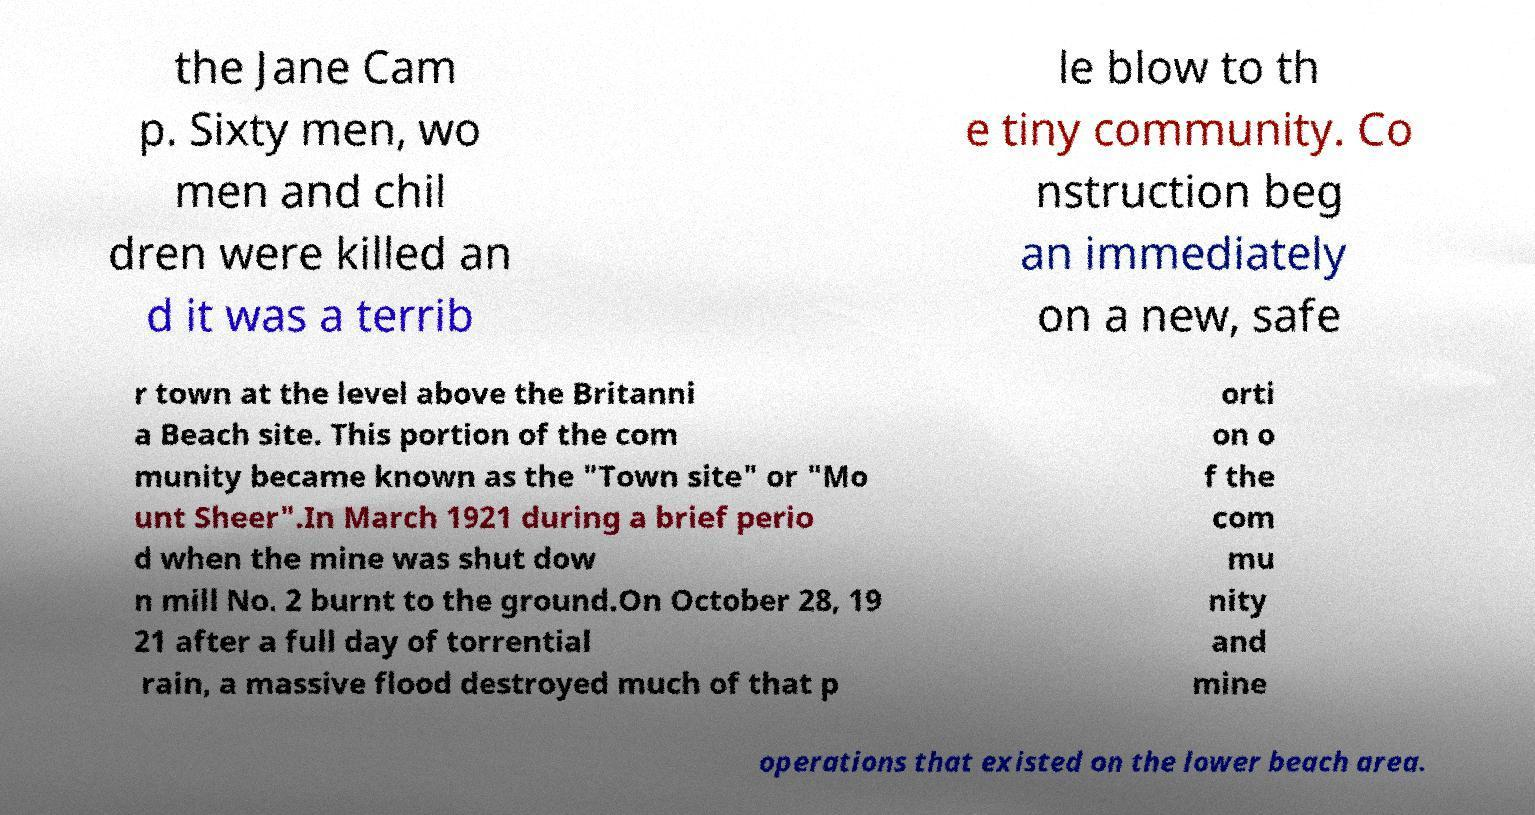Could you assist in decoding the text presented in this image and type it out clearly? the Jane Cam p. Sixty men, wo men and chil dren were killed an d it was a terrib le blow to th e tiny community. Co nstruction beg an immediately on a new, safe r town at the level above the Britanni a Beach site. This portion of the com munity became known as the "Town site" or "Mo unt Sheer".In March 1921 during a brief perio d when the mine was shut dow n mill No. 2 burnt to the ground.On October 28, 19 21 after a full day of torrential rain, a massive flood destroyed much of that p orti on o f the com mu nity and mine operations that existed on the lower beach area. 